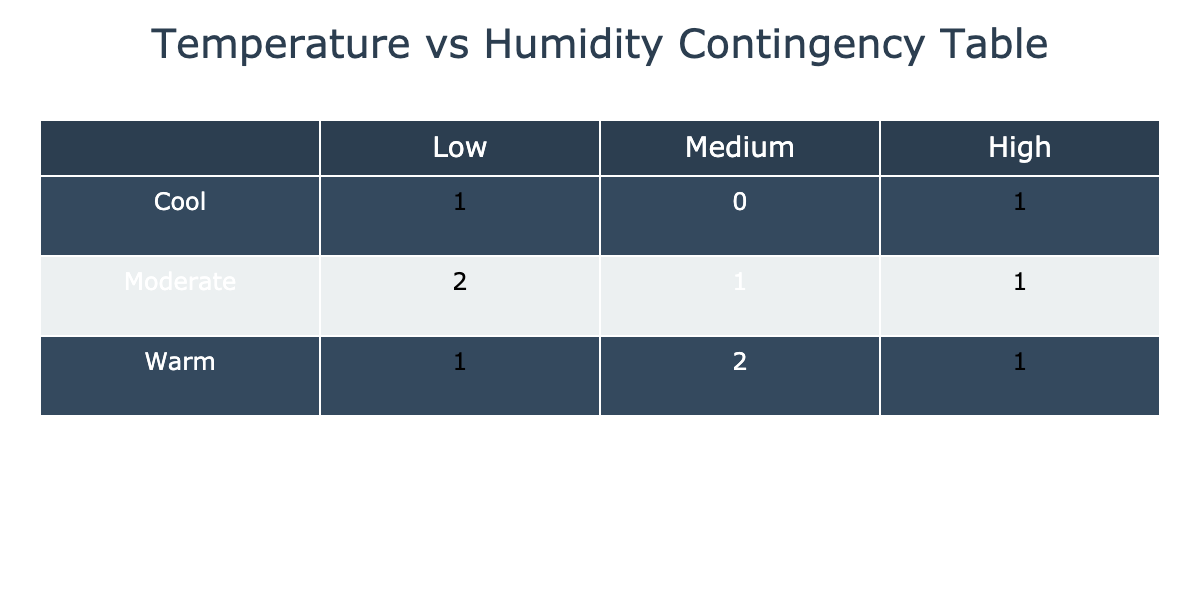What is the number of rooms categorized as 'Warm' and 'High' humidity? From the contingency table, I need to check the 'Warm' row and 'High' column. The intersection shows that there are 2 rooms that are both 'Warm' in temperature and have 'High' humidity.
Answer: 2 Which room has the highest temperature and what category does it fall into? Looking at the temperature values, the Garage has the highest temperature at 81°F. Referring to the temperature categories, 81°F falls into the 'Warm' category.
Answer: Garage, Warm Is there any room categorized as 'Cool' with 'Medium' humidity? I will look at the 'Cool' row and 'Medium' column in the table. There are 0 rooms that fall into this category as 'Cool' rooms only have a count for 'Low' humidity.
Answer: No What is the total number of rooms that are categorized as 'Moderate'? I will sum the counts of the 'Moderate' row from the table. The row has 4 rooms categorized as 'Moderate' in total.
Answer: 4 How many rooms have a 'Low' humidity level, and what is the average temperature of those rooms? I check the 'Low' column, which shows that there are 3 rooms. Now, finding their temperatures: Living Room (75°F), Office (74°F), and Garage (81°F). The average temperature is (75 + 74 + 81)/3 = 76.67°F.
Answer: 3, 76.67°F Is there a room in the 'Moderate' temperature category with 'High' humidity? Reviewing the 'Moderate' row and 'High' humidity column, there are no rooms listed in that intersection.
Answer: No What is the difference in room counts between 'Cool' and 'Warm' categories? From the contingency table, there is 1 room categorized as 'Cool' and 3 rooms categorized as 'Warm'. The difference is 3 - 1 = 2.
Answer: 2 Which humidity category has the highest count of rooms, and how many rooms fall into that category? By checking each humidity category, I find that both 'Medium' and 'High' categories have 3 rooms, while 'Low' has 2. The highest count is 3 rooms each in 'Medium' and 'High'.
Answer: Medium/High, 3 rooms 